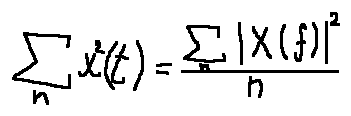<formula> <loc_0><loc_0><loc_500><loc_500>\sum \lim i t s _ { n } x ^ { 2 } ( t ) = \frac { \sum \lim i t s _ { n } | X ( f ) | ^ { 2 } } { n }</formula> 